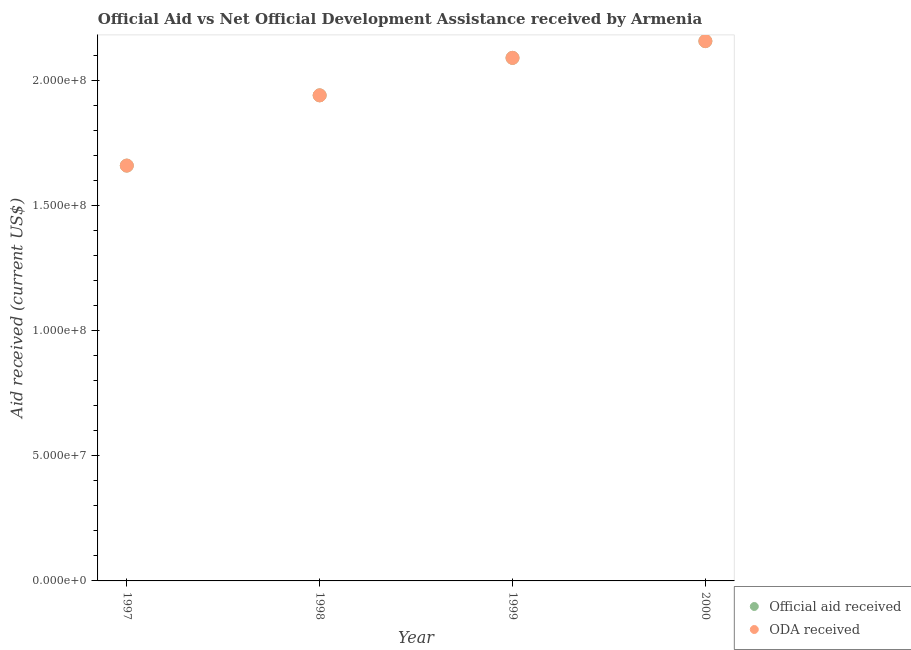How many different coloured dotlines are there?
Your response must be concise. 2. Is the number of dotlines equal to the number of legend labels?
Provide a succinct answer. Yes. What is the oda received in 1997?
Ensure brevity in your answer.  1.66e+08. Across all years, what is the maximum official aid received?
Your response must be concise. 2.16e+08. Across all years, what is the minimum oda received?
Your response must be concise. 1.66e+08. In which year was the official aid received maximum?
Your response must be concise. 2000. What is the total oda received in the graph?
Offer a very short reply. 7.85e+08. What is the difference between the oda received in 1997 and that in 1999?
Your response must be concise. -4.31e+07. What is the difference between the official aid received in 1997 and the oda received in 1998?
Your response must be concise. -2.81e+07. What is the average official aid received per year?
Make the answer very short. 1.96e+08. In how many years, is the official aid received greater than 40000000 US$?
Offer a terse response. 4. What is the ratio of the official aid received in 1997 to that in 1999?
Provide a short and direct response. 0.79. Is the oda received in 1997 less than that in 1998?
Keep it short and to the point. Yes. Is the difference between the oda received in 1998 and 1999 greater than the difference between the official aid received in 1998 and 1999?
Your answer should be very brief. No. What is the difference between the highest and the second highest official aid received?
Provide a succinct answer. 6.71e+06. What is the difference between the highest and the lowest official aid received?
Ensure brevity in your answer.  4.98e+07. In how many years, is the official aid received greater than the average official aid received taken over all years?
Give a very brief answer. 2. Is the sum of the official aid received in 1998 and 2000 greater than the maximum oda received across all years?
Offer a very short reply. Yes. Is the oda received strictly greater than the official aid received over the years?
Offer a very short reply. No. Are the values on the major ticks of Y-axis written in scientific E-notation?
Provide a succinct answer. Yes. How many legend labels are there?
Your answer should be very brief. 2. How are the legend labels stacked?
Your answer should be compact. Vertical. What is the title of the graph?
Offer a terse response. Official Aid vs Net Official Development Assistance received by Armenia . Does "Primary education" appear as one of the legend labels in the graph?
Provide a short and direct response. No. What is the label or title of the X-axis?
Provide a succinct answer. Year. What is the label or title of the Y-axis?
Your answer should be compact. Aid received (current US$). What is the Aid received (current US$) of Official aid received in 1997?
Your response must be concise. 1.66e+08. What is the Aid received (current US$) of ODA received in 1997?
Ensure brevity in your answer.  1.66e+08. What is the Aid received (current US$) in Official aid received in 1998?
Offer a very short reply. 1.94e+08. What is the Aid received (current US$) of ODA received in 1998?
Offer a very short reply. 1.94e+08. What is the Aid received (current US$) in Official aid received in 1999?
Provide a succinct answer. 2.09e+08. What is the Aid received (current US$) of ODA received in 1999?
Offer a terse response. 2.09e+08. What is the Aid received (current US$) of Official aid received in 2000?
Provide a short and direct response. 2.16e+08. What is the Aid received (current US$) of ODA received in 2000?
Make the answer very short. 2.16e+08. Across all years, what is the maximum Aid received (current US$) in Official aid received?
Provide a short and direct response. 2.16e+08. Across all years, what is the maximum Aid received (current US$) in ODA received?
Provide a short and direct response. 2.16e+08. Across all years, what is the minimum Aid received (current US$) in Official aid received?
Your answer should be very brief. 1.66e+08. Across all years, what is the minimum Aid received (current US$) of ODA received?
Keep it short and to the point. 1.66e+08. What is the total Aid received (current US$) of Official aid received in the graph?
Ensure brevity in your answer.  7.85e+08. What is the total Aid received (current US$) of ODA received in the graph?
Keep it short and to the point. 7.85e+08. What is the difference between the Aid received (current US$) in Official aid received in 1997 and that in 1998?
Your response must be concise. -2.81e+07. What is the difference between the Aid received (current US$) of ODA received in 1997 and that in 1998?
Make the answer very short. -2.81e+07. What is the difference between the Aid received (current US$) of Official aid received in 1997 and that in 1999?
Offer a terse response. -4.31e+07. What is the difference between the Aid received (current US$) of ODA received in 1997 and that in 1999?
Provide a succinct answer. -4.31e+07. What is the difference between the Aid received (current US$) in Official aid received in 1997 and that in 2000?
Your answer should be very brief. -4.98e+07. What is the difference between the Aid received (current US$) in ODA received in 1997 and that in 2000?
Make the answer very short. -4.98e+07. What is the difference between the Aid received (current US$) of Official aid received in 1998 and that in 1999?
Offer a very short reply. -1.50e+07. What is the difference between the Aid received (current US$) of ODA received in 1998 and that in 1999?
Provide a succinct answer. -1.50e+07. What is the difference between the Aid received (current US$) in Official aid received in 1998 and that in 2000?
Give a very brief answer. -2.17e+07. What is the difference between the Aid received (current US$) in ODA received in 1998 and that in 2000?
Your answer should be very brief. -2.17e+07. What is the difference between the Aid received (current US$) of Official aid received in 1999 and that in 2000?
Your answer should be very brief. -6.71e+06. What is the difference between the Aid received (current US$) in ODA received in 1999 and that in 2000?
Keep it short and to the point. -6.71e+06. What is the difference between the Aid received (current US$) of Official aid received in 1997 and the Aid received (current US$) of ODA received in 1998?
Offer a terse response. -2.81e+07. What is the difference between the Aid received (current US$) in Official aid received in 1997 and the Aid received (current US$) in ODA received in 1999?
Your answer should be compact. -4.31e+07. What is the difference between the Aid received (current US$) of Official aid received in 1997 and the Aid received (current US$) of ODA received in 2000?
Provide a short and direct response. -4.98e+07. What is the difference between the Aid received (current US$) in Official aid received in 1998 and the Aid received (current US$) in ODA received in 1999?
Offer a very short reply. -1.50e+07. What is the difference between the Aid received (current US$) in Official aid received in 1998 and the Aid received (current US$) in ODA received in 2000?
Give a very brief answer. -2.17e+07. What is the difference between the Aid received (current US$) in Official aid received in 1999 and the Aid received (current US$) in ODA received in 2000?
Keep it short and to the point. -6.71e+06. What is the average Aid received (current US$) of Official aid received per year?
Offer a terse response. 1.96e+08. What is the average Aid received (current US$) in ODA received per year?
Provide a short and direct response. 1.96e+08. In the year 1997, what is the difference between the Aid received (current US$) of Official aid received and Aid received (current US$) of ODA received?
Offer a very short reply. 0. In the year 1998, what is the difference between the Aid received (current US$) in Official aid received and Aid received (current US$) in ODA received?
Ensure brevity in your answer.  0. In the year 1999, what is the difference between the Aid received (current US$) of Official aid received and Aid received (current US$) of ODA received?
Your answer should be very brief. 0. In the year 2000, what is the difference between the Aid received (current US$) in Official aid received and Aid received (current US$) in ODA received?
Your response must be concise. 0. What is the ratio of the Aid received (current US$) of Official aid received in 1997 to that in 1998?
Your answer should be very brief. 0.86. What is the ratio of the Aid received (current US$) in ODA received in 1997 to that in 1998?
Provide a short and direct response. 0.86. What is the ratio of the Aid received (current US$) of Official aid received in 1997 to that in 1999?
Your answer should be compact. 0.79. What is the ratio of the Aid received (current US$) of ODA received in 1997 to that in 1999?
Your answer should be very brief. 0.79. What is the ratio of the Aid received (current US$) in Official aid received in 1997 to that in 2000?
Make the answer very short. 0.77. What is the ratio of the Aid received (current US$) in ODA received in 1997 to that in 2000?
Offer a terse response. 0.77. What is the ratio of the Aid received (current US$) in Official aid received in 1998 to that in 1999?
Your answer should be very brief. 0.93. What is the ratio of the Aid received (current US$) of ODA received in 1998 to that in 1999?
Provide a succinct answer. 0.93. What is the ratio of the Aid received (current US$) in Official aid received in 1998 to that in 2000?
Offer a very short reply. 0.9. What is the ratio of the Aid received (current US$) of ODA received in 1998 to that in 2000?
Give a very brief answer. 0.9. What is the ratio of the Aid received (current US$) in Official aid received in 1999 to that in 2000?
Give a very brief answer. 0.97. What is the ratio of the Aid received (current US$) in ODA received in 1999 to that in 2000?
Provide a short and direct response. 0.97. What is the difference between the highest and the second highest Aid received (current US$) in Official aid received?
Ensure brevity in your answer.  6.71e+06. What is the difference between the highest and the second highest Aid received (current US$) in ODA received?
Your response must be concise. 6.71e+06. What is the difference between the highest and the lowest Aid received (current US$) of Official aid received?
Keep it short and to the point. 4.98e+07. What is the difference between the highest and the lowest Aid received (current US$) of ODA received?
Provide a short and direct response. 4.98e+07. 